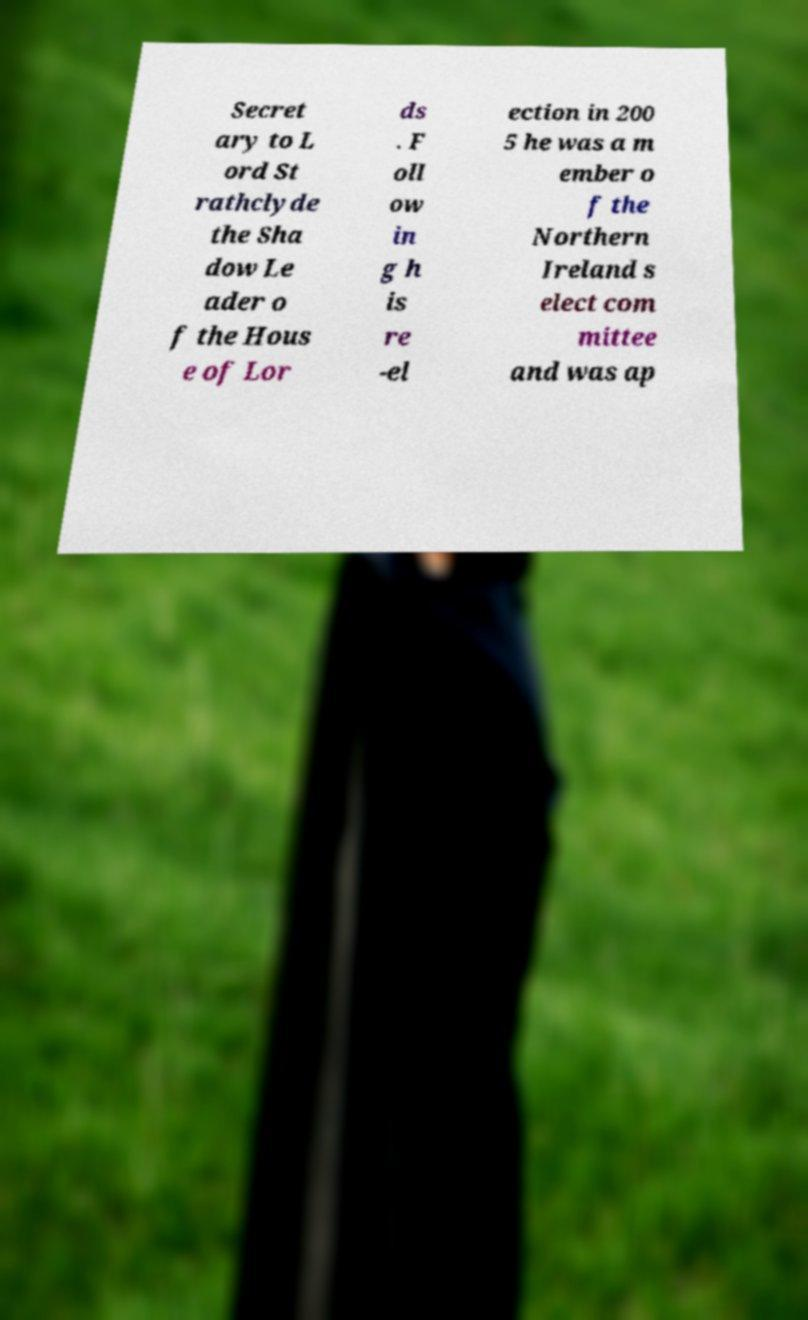Please read and relay the text visible in this image. What does it say? Secret ary to L ord St rathclyde the Sha dow Le ader o f the Hous e of Lor ds . F oll ow in g h is re -el ection in 200 5 he was a m ember o f the Northern Ireland s elect com mittee and was ap 